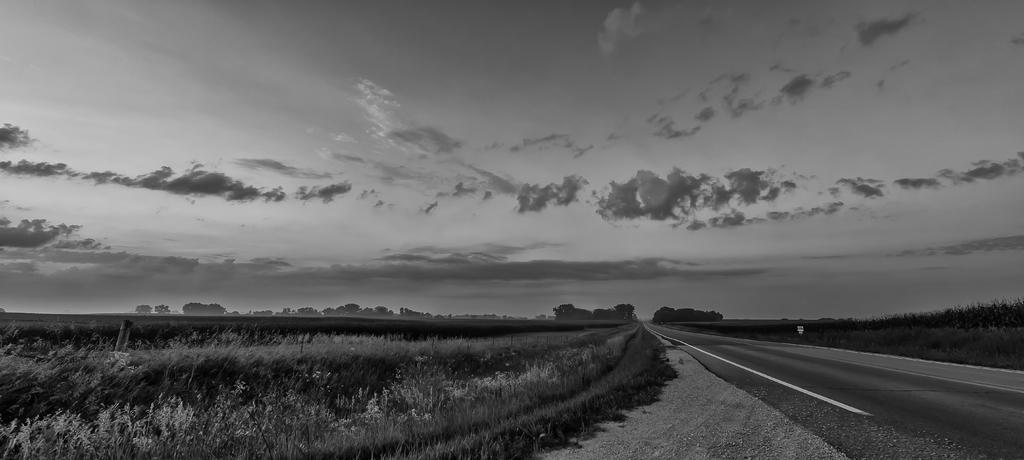What is the color scheme of the image? The image is black and white. What can be seen on the ground in the image? There is a pathway in the image. What type of vegetation is present in the image? There is a group of plants and grass in the image. What is the boundary feature in the image? There is a fence in the image. What is the purpose of the signboard in the image? The signboard in the image provides information or directions. What is the weather condition in the image? The sky is visible in the image and appears cloudy. Can you tell me how many attempts the person made to drive through the fence in the image? There is no person or driving activity present in the image; it features a pathway, plants, grass, fence, and signboard. 